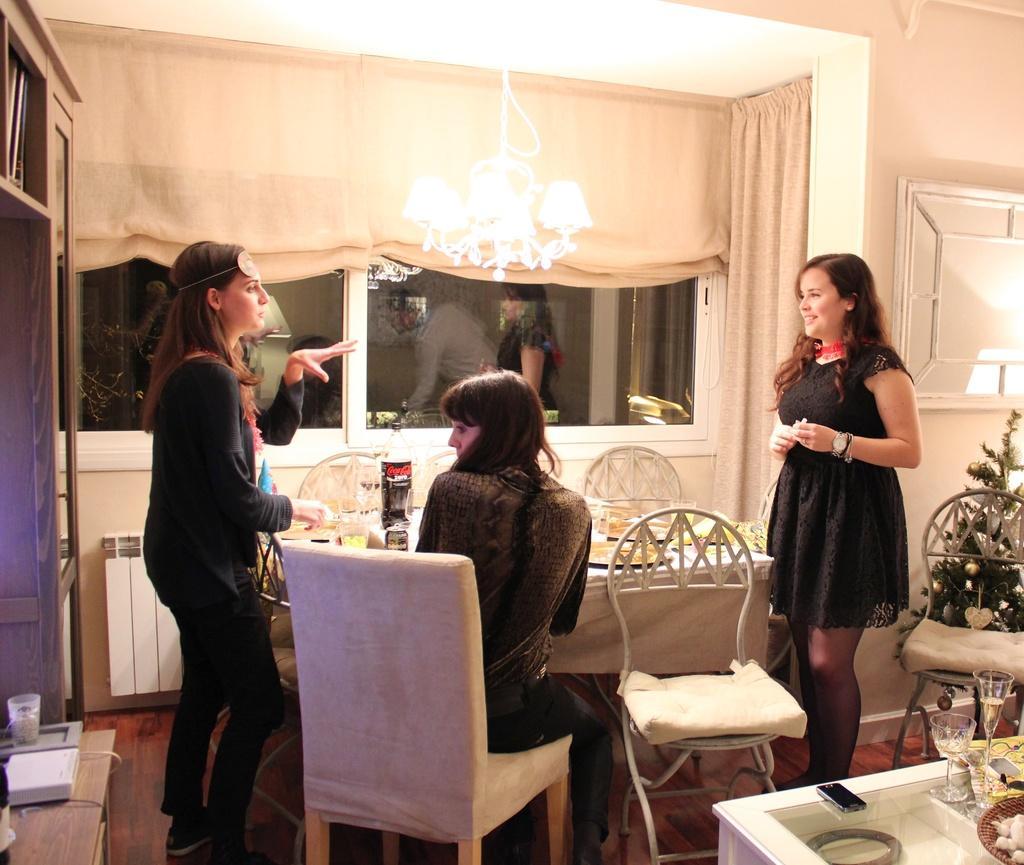In one or two sentences, can you explain what this image depicts? In this picture we can see two woman standing and talking and smiling and here woman sitting on chair and in front of them there is table and on table we can see glass, plate and in background we can see curtain, window, wall. 